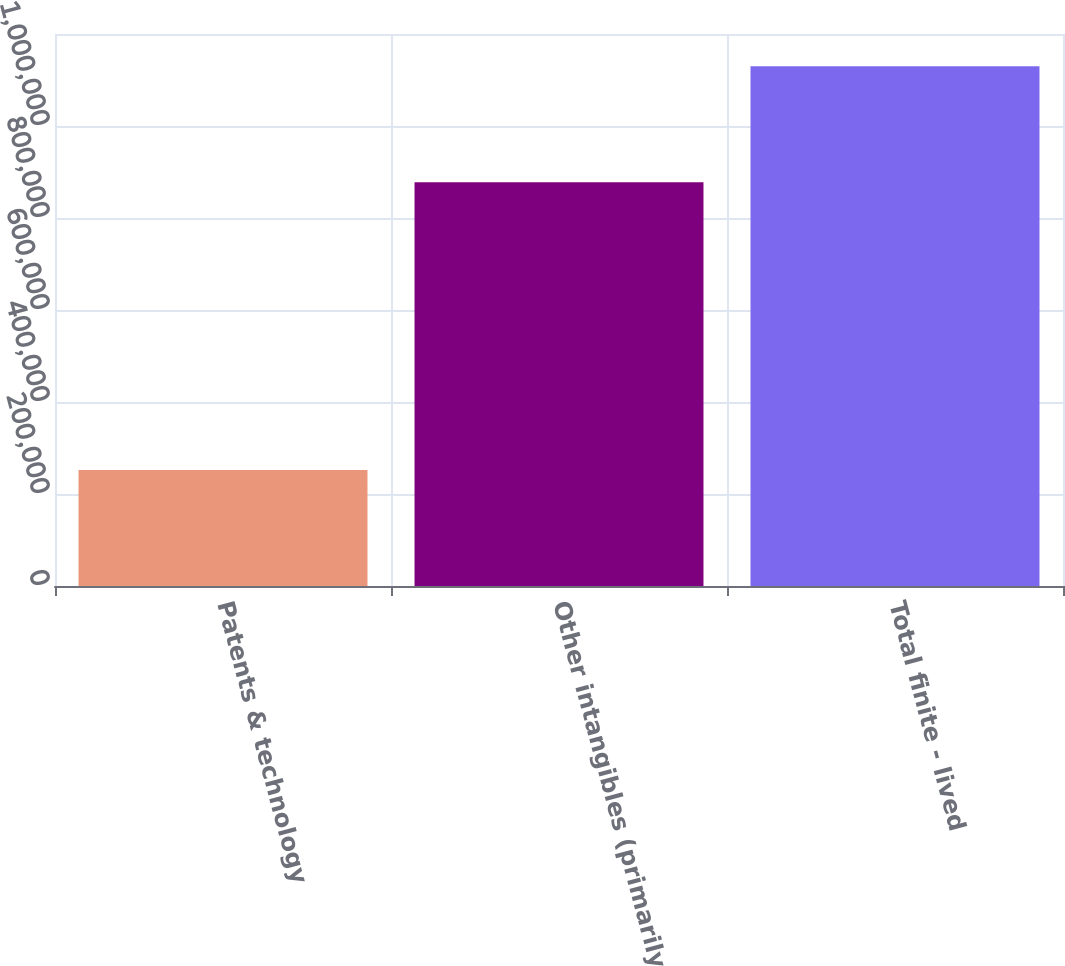Convert chart. <chart><loc_0><loc_0><loc_500><loc_500><bar_chart><fcel>Patents & technology<fcel>Other intangibles (primarily<fcel>Total finite - lived<nl><fcel>252180<fcel>877452<fcel>1.12963e+06<nl></chart> 